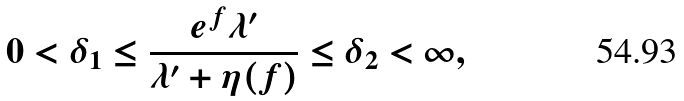Convert formula to latex. <formula><loc_0><loc_0><loc_500><loc_500>0 < \delta _ { 1 } \leq \frac { e ^ { f } \lambda ^ { \prime } } { \lambda ^ { \prime } + \eta ( f ) } \leq \delta _ { 2 } < \infty ,</formula> 